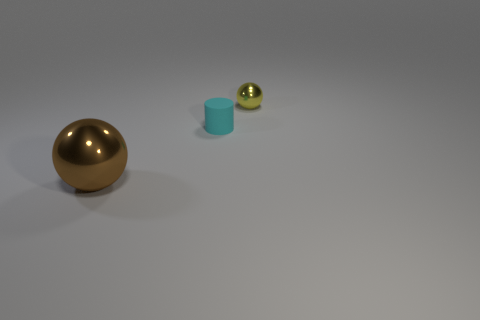What can you infer about the setting or context where these objects are placed? The setting appears to be a neutral studio environment, often used in product photography or 3D modeling to showcase objects without any distractions. The soft shadows indicate a diffused light source, providing a context that emphasizes the objects themselves. 